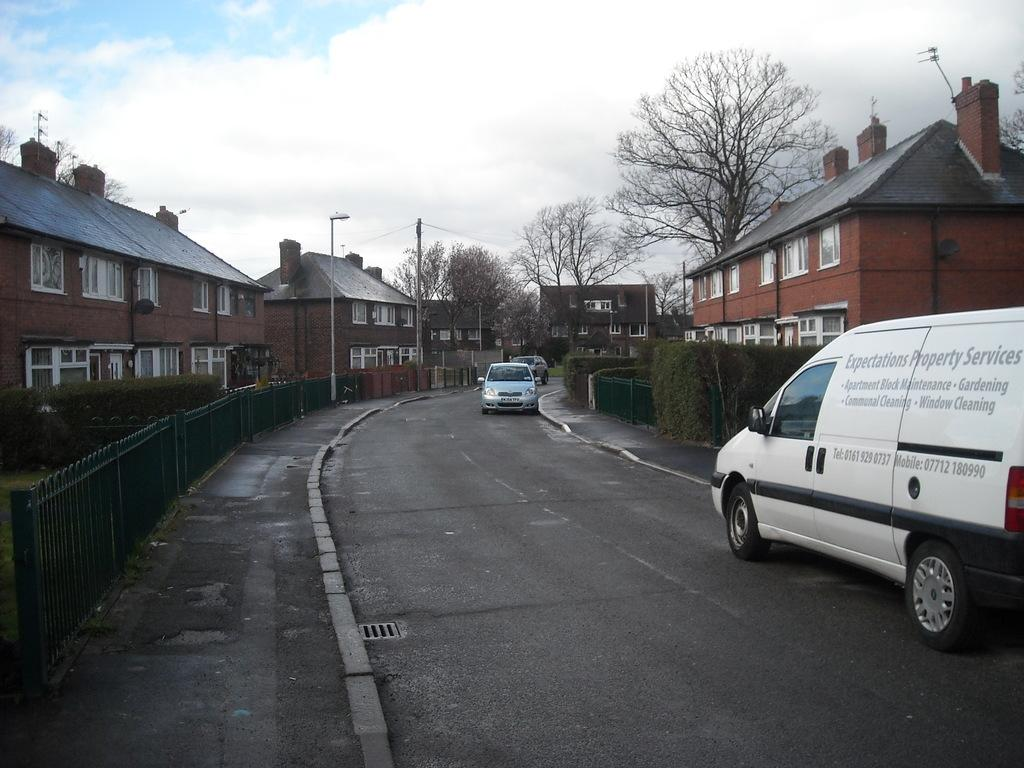<image>
Describe the image concisely. A white van with the words "Expectations Property Services" on it 